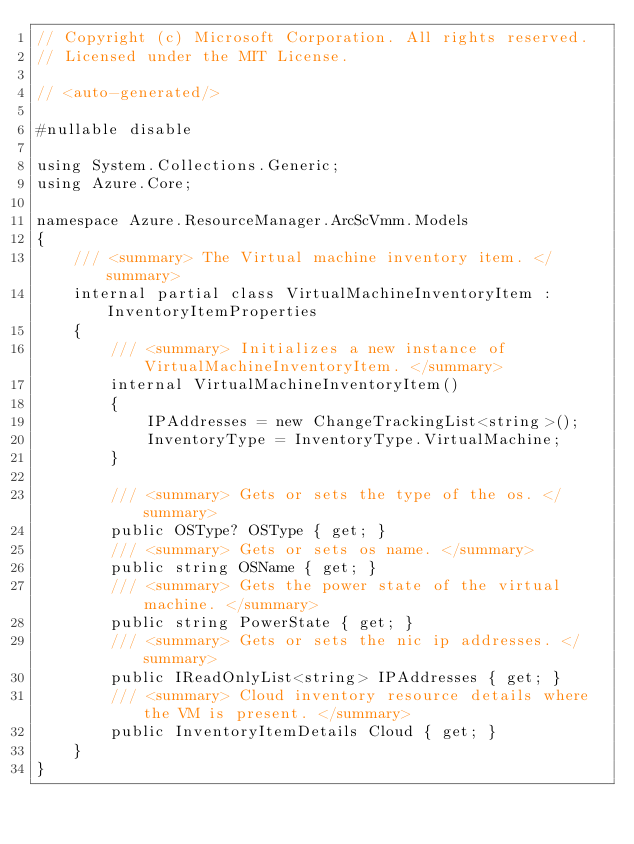Convert code to text. <code><loc_0><loc_0><loc_500><loc_500><_C#_>// Copyright (c) Microsoft Corporation. All rights reserved.
// Licensed under the MIT License.

// <auto-generated/>

#nullable disable

using System.Collections.Generic;
using Azure.Core;

namespace Azure.ResourceManager.ArcScVmm.Models
{
    /// <summary> The Virtual machine inventory item. </summary>
    internal partial class VirtualMachineInventoryItem : InventoryItemProperties
    {
        /// <summary> Initializes a new instance of VirtualMachineInventoryItem. </summary>
        internal VirtualMachineInventoryItem()
        {
            IPAddresses = new ChangeTrackingList<string>();
            InventoryType = InventoryType.VirtualMachine;
        }

        /// <summary> Gets or sets the type of the os. </summary>
        public OSType? OSType { get; }
        /// <summary> Gets or sets os name. </summary>
        public string OSName { get; }
        /// <summary> Gets the power state of the virtual machine. </summary>
        public string PowerState { get; }
        /// <summary> Gets or sets the nic ip addresses. </summary>
        public IReadOnlyList<string> IPAddresses { get; }
        /// <summary> Cloud inventory resource details where the VM is present. </summary>
        public InventoryItemDetails Cloud { get; }
    }
}
</code> 